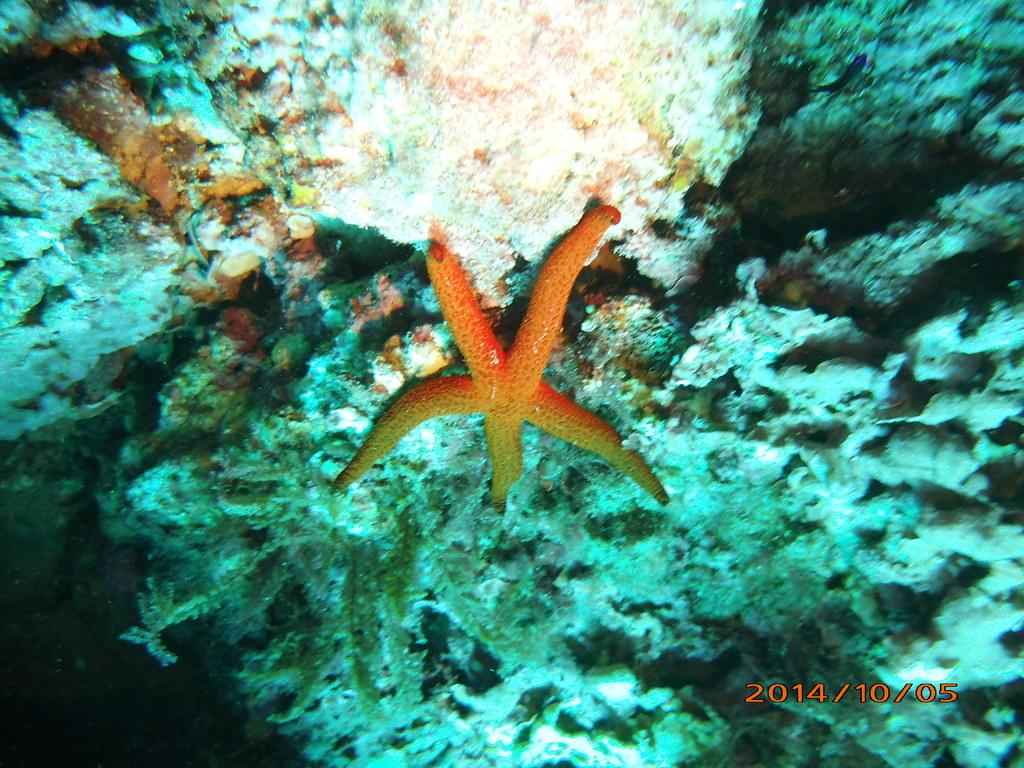What type of animals can be seen in the image? There are aquatic animals in the image. What else is present in the image besides the animals? There are plants in the image. Is there any text or marking in the image? Yes, there is a watermark in the right bottom of the image. How many fingers can be seen measuring the length of the aquatic animals in the image? There are no fingers or measuring in the image; it only features aquatic animals and plants. 